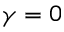<formula> <loc_0><loc_0><loc_500><loc_500>\gamma = 0</formula> 